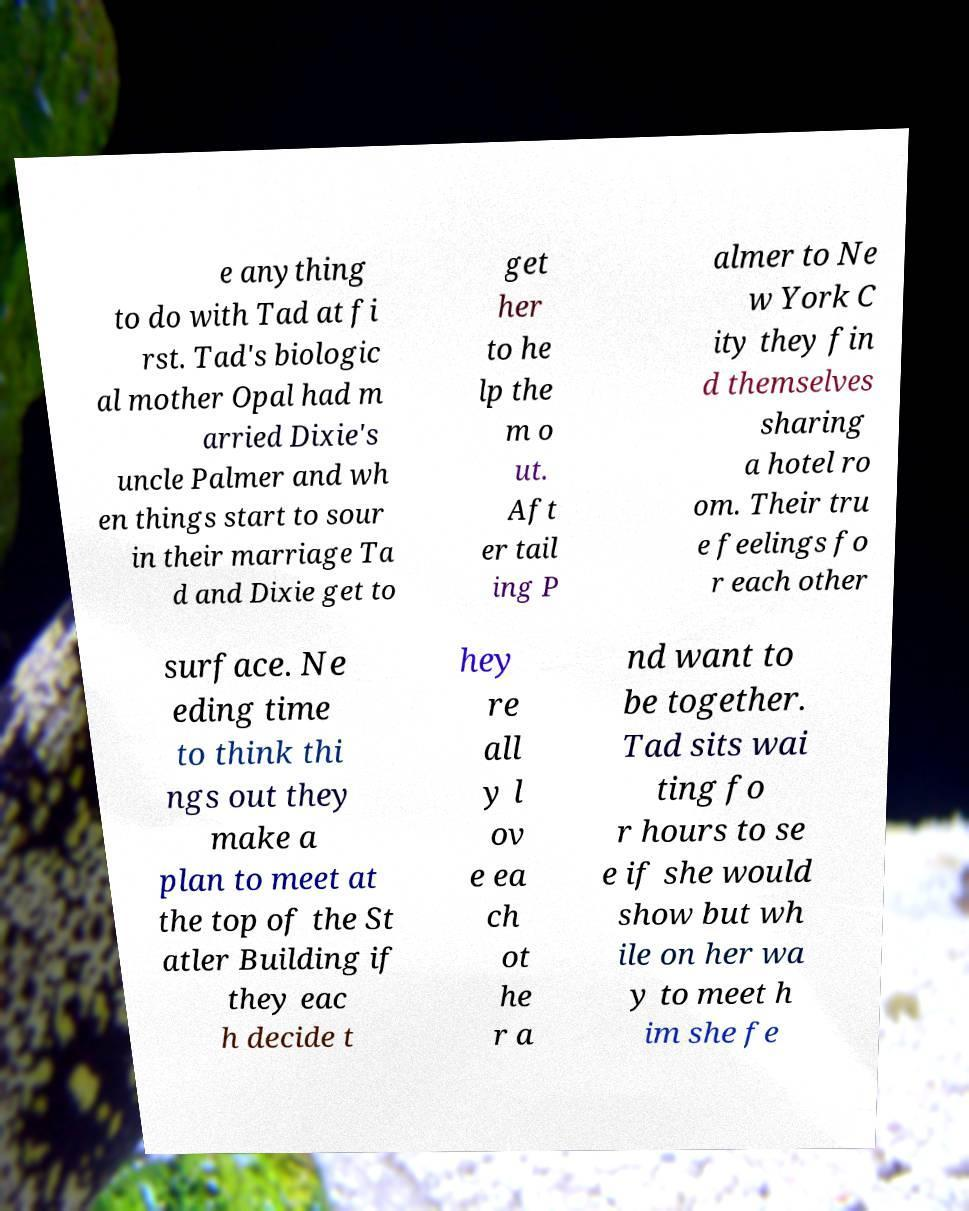I need the written content from this picture converted into text. Can you do that? e anything to do with Tad at fi rst. Tad's biologic al mother Opal had m arried Dixie's uncle Palmer and wh en things start to sour in their marriage Ta d and Dixie get to get her to he lp the m o ut. Aft er tail ing P almer to Ne w York C ity they fin d themselves sharing a hotel ro om. Their tru e feelings fo r each other surface. Ne eding time to think thi ngs out they make a plan to meet at the top of the St atler Building if they eac h decide t hey re all y l ov e ea ch ot he r a nd want to be together. Tad sits wai ting fo r hours to se e if she would show but wh ile on her wa y to meet h im she fe 